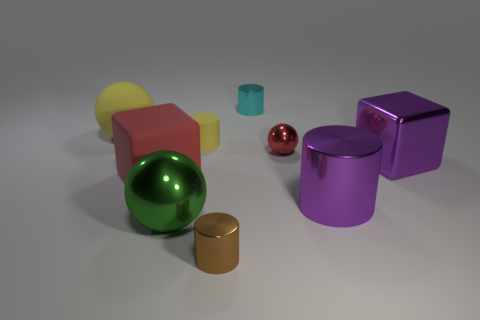Add 1 yellow matte spheres. How many objects exist? 10 Subtract all blocks. How many objects are left? 7 Add 8 red rubber things. How many red rubber things are left? 9 Add 2 small cylinders. How many small cylinders exist? 5 Subtract 1 yellow balls. How many objects are left? 8 Subtract all gray rubber cubes. Subtract all large red matte blocks. How many objects are left? 8 